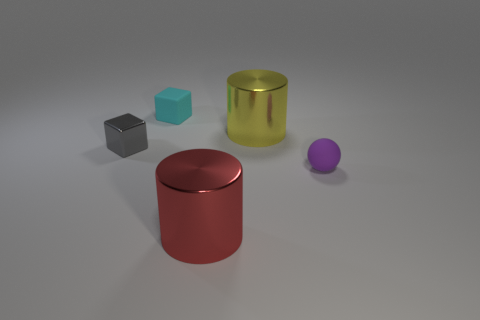Add 4 large yellow metal cubes. How many objects exist? 9 Subtract all cylinders. How many objects are left? 3 Add 4 large red objects. How many large red objects are left? 5 Add 3 large red metal cylinders. How many large red metal cylinders exist? 4 Subtract 0 green cubes. How many objects are left? 5 Subtract all tiny gray things. Subtract all large blue cubes. How many objects are left? 4 